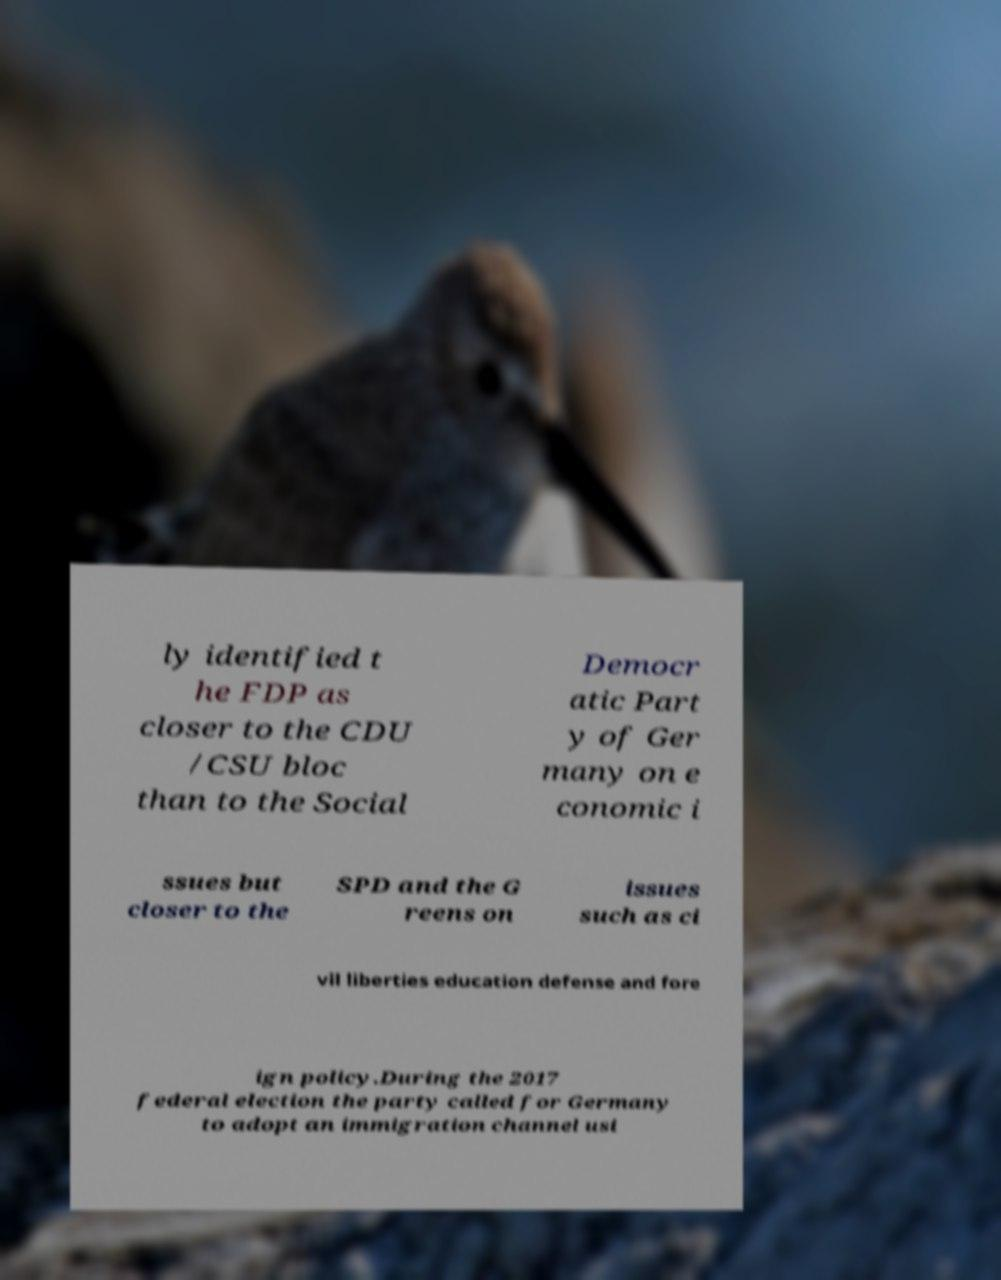Can you read and provide the text displayed in the image?This photo seems to have some interesting text. Can you extract and type it out for me? ly identified t he FDP as closer to the CDU /CSU bloc than to the Social Democr atic Part y of Ger many on e conomic i ssues but closer to the SPD and the G reens on issues such as ci vil liberties education defense and fore ign policy.During the 2017 federal election the party called for Germany to adopt an immigration channel usi 